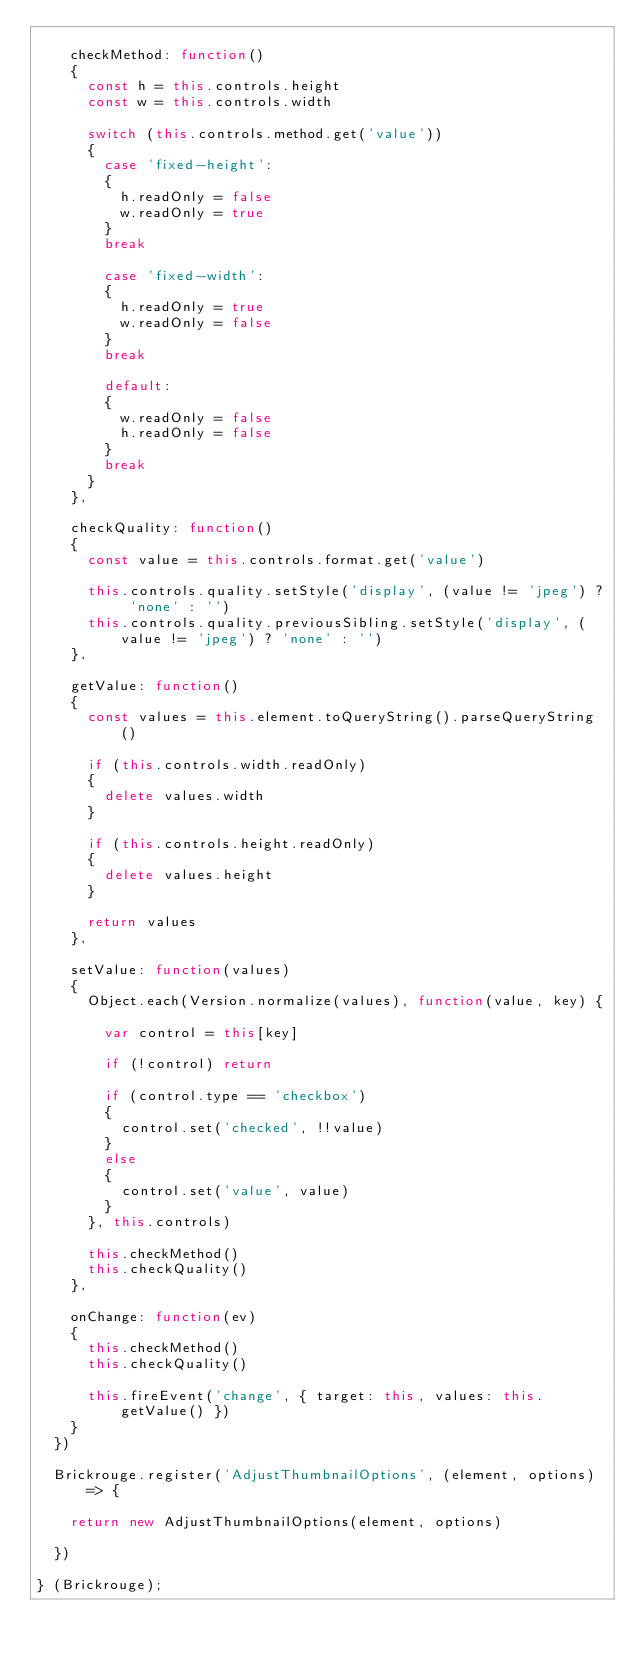<code> <loc_0><loc_0><loc_500><loc_500><_JavaScript_>
		checkMethod: function()
		{
			const h = this.controls.height
			const w = this.controls.width

			switch (this.controls.method.get('value'))
			{
				case 'fixed-height':
				{
					h.readOnly = false
					w.readOnly = true
				}
				break

				case 'fixed-width':
				{
					h.readOnly = true
					w.readOnly = false
				}
				break

				default:
				{
					w.readOnly = false
					h.readOnly = false
				}
				break
			}
		},

		checkQuality: function()
		{
			const value = this.controls.format.get('value')

			this.controls.quality.setStyle('display', (value != 'jpeg') ? 'none' : '')
			this.controls.quality.previousSibling.setStyle('display', (value != 'jpeg') ? 'none' : '')
		},

		getValue: function()
		{
			const values = this.element.toQueryString().parseQueryString()

			if (this.controls.width.readOnly)
			{
				delete values.width
			}

			if (this.controls.height.readOnly)
			{
				delete values.height
			}

			return values
		},

		setValue: function(values)
		{
			Object.each(Version.normalize(values), function(value, key) {

				var control = this[key]

				if (!control) return

				if (control.type == 'checkbox')
				{
					control.set('checked', !!value)
				}
				else
				{
					control.set('value', value)
				}
			}, this.controls)

			this.checkMethod()
			this.checkQuality()
		},

		onChange: function(ev)
		{
			this.checkMethod()
			this.checkQuality()

			this.fireEvent('change', { target: this, values: this.getValue() })
		}
	})

	Brickrouge.register('AdjustThumbnailOptions', (element, options) => {

		return new AdjustThumbnailOptions(element, options)

	})

} (Brickrouge);
</code> 